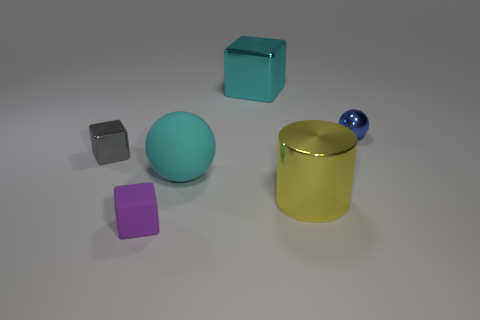Add 1 small green rubber cylinders. How many objects exist? 7 Subtract all cylinders. How many objects are left? 5 Subtract all tiny blue shiny objects. Subtract all gray things. How many objects are left? 4 Add 6 matte balls. How many matte balls are left? 7 Add 1 green cubes. How many green cubes exist? 1 Subtract 0 blue cylinders. How many objects are left? 6 